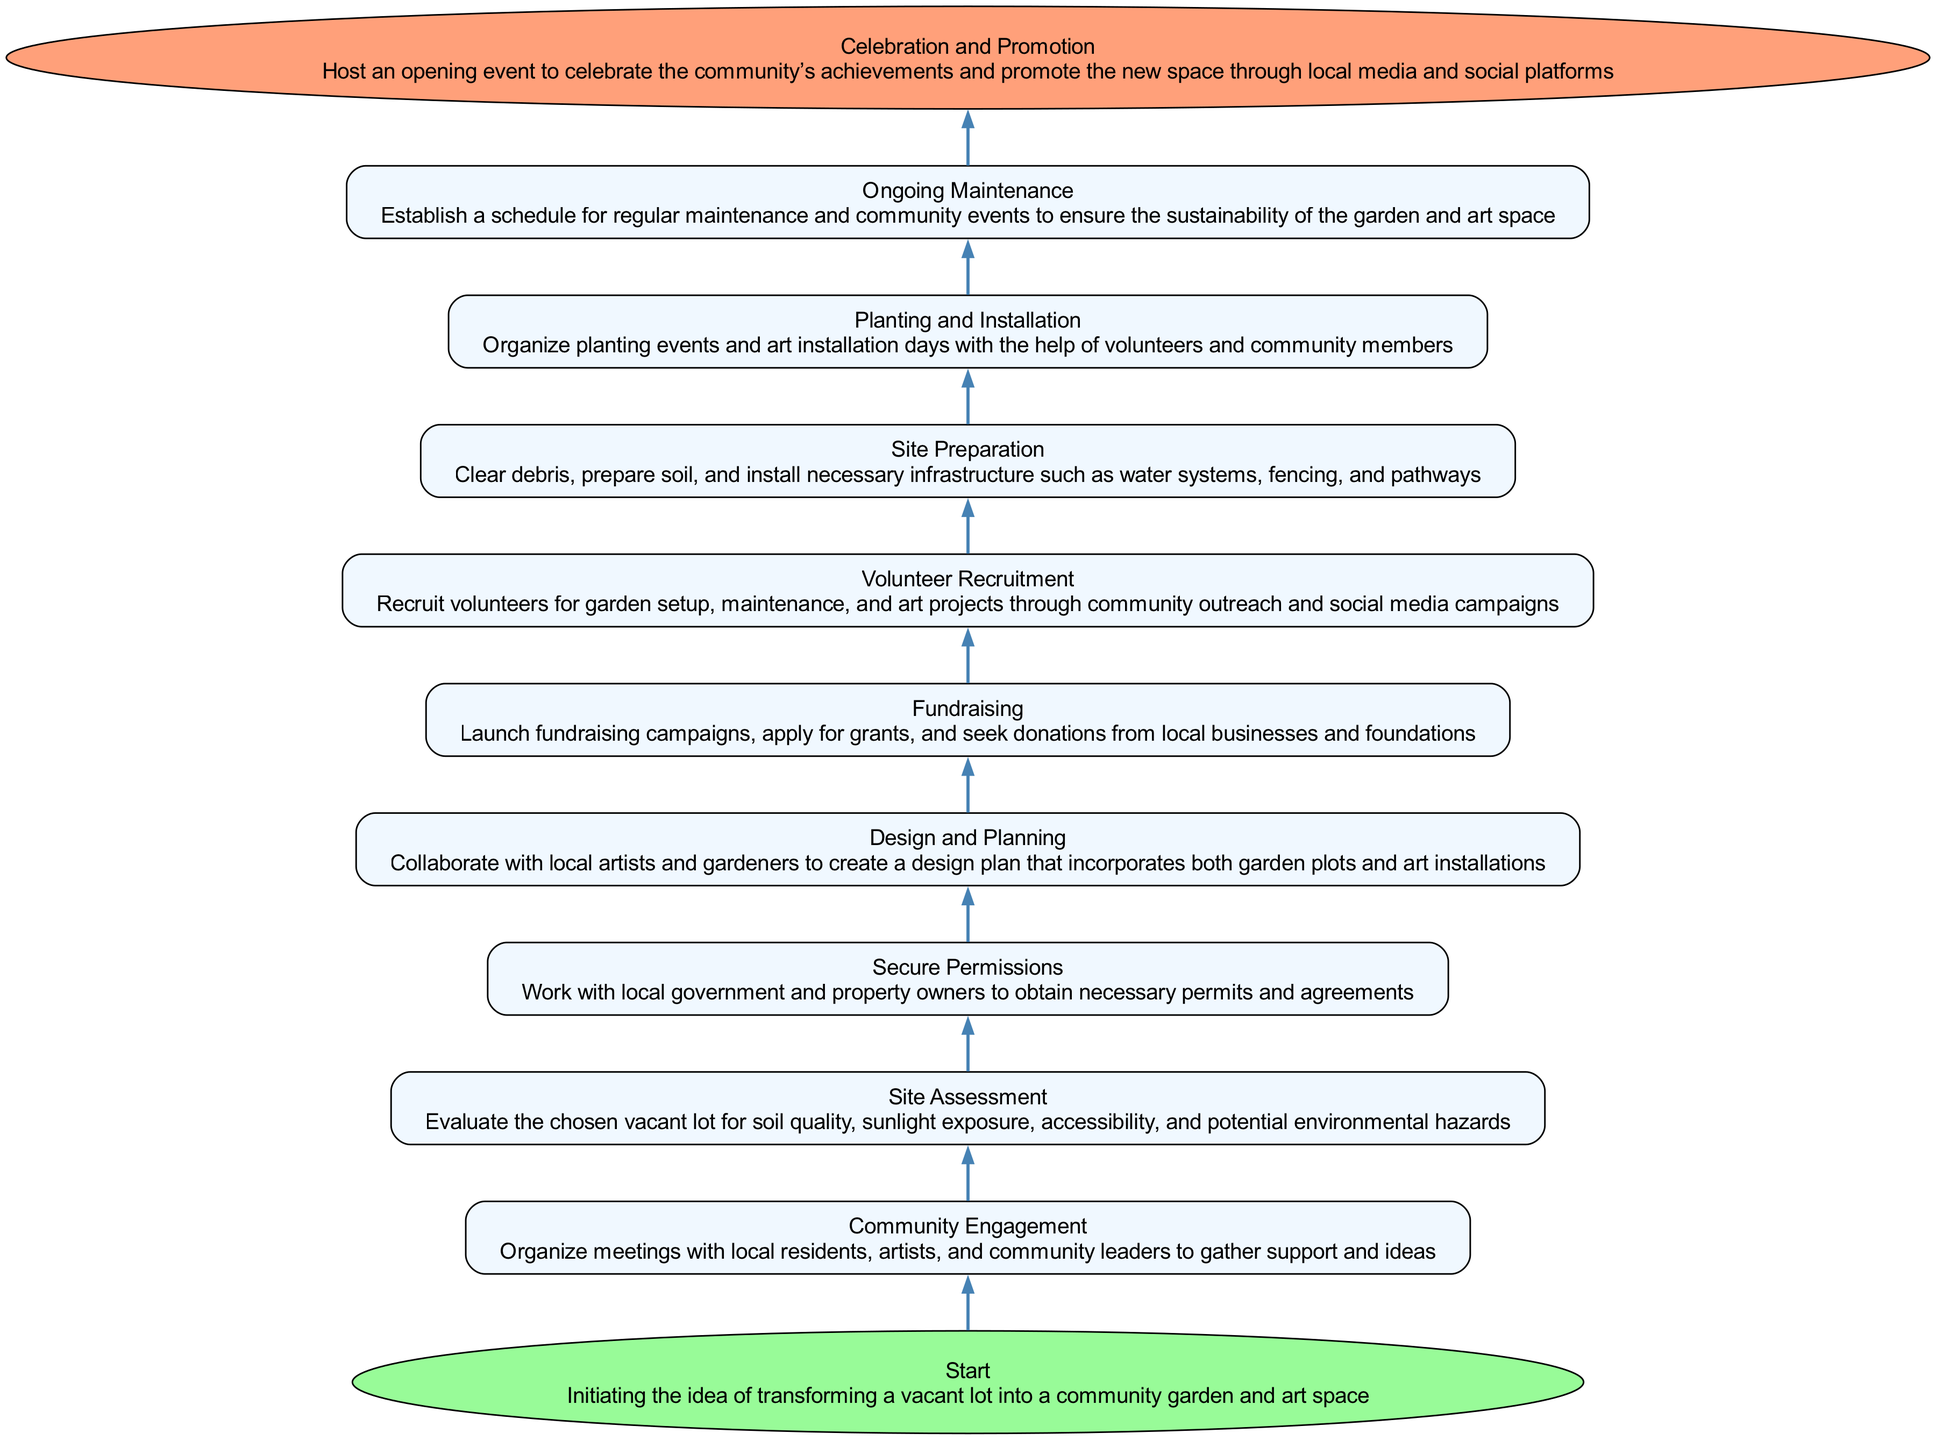What is the first step in establishing a community garden? The first step is labeled as "Start", which represents the initiation of the idea to transform a vacant lot.
Answer: Start How many total steps are there in the process? By counting the nodes described in the diagram, there are 11 steps outlined from start to finish.
Answer: 11 What action follows "Community Engagement"? After "Community Engagement", the next action is "Site Assessment", indicating the evaluation of the chosen vacant lot.
Answer: Site Assessment Which step involves collaborating with local artists? The step "Design and Planning" includes collaboration with local artists to create a design plan that incorporates garden plots and art installations.
Answer: Design and Planning What is the final step in the process? The final step is "Celebration and Promotion", which involves hosting an event to celebrate the community's achievements and promote the new space.
Answer: Celebration and Promotion What step requires obtaining permits and agreements? The step titled "Secure Permissions" involves working with government and property owners to obtain necessary permits and agreements.
Answer: Secure Permissions Which step must be completed before planting events can take place? Before planting events can take place, the "Site Preparation" step must be completed, which includes clearing debris and preparing the soil.
Answer: Site Preparation What is the purpose of "Ongoing Maintenance"? "Ongoing Maintenance" establishes a schedule for regular upkeep of the garden and art space, ensuring sustainability over time.
Answer: sustainability What type of events are associated with "Volunteer Recruitment"? "Volunteer Recruitment" is associated with garden setup, maintenance, and art projects, which are done through community outreach campaigns.
Answer: community outreach 